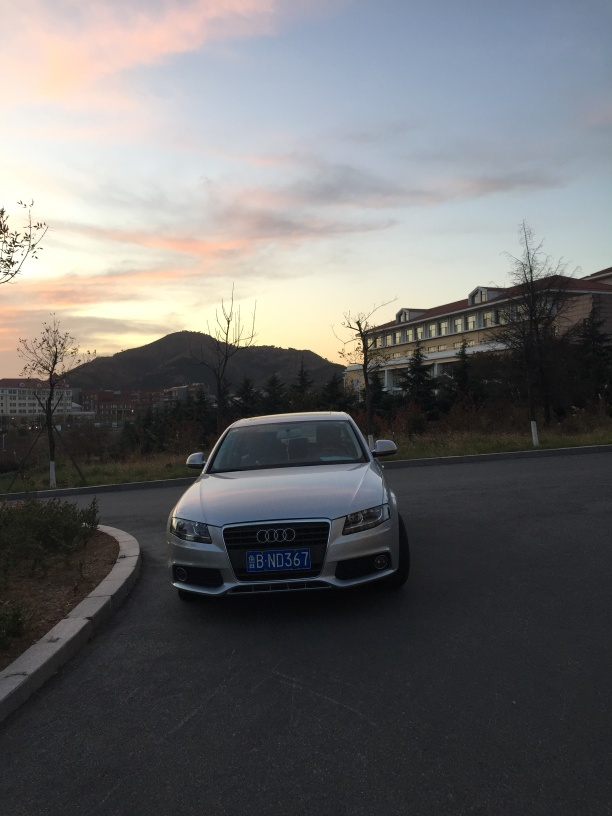What can you tell me about the car's position in the environment? The car is positioned on the side of a paved road, facing the camera. It is not parked within the designated parking spaces to the right but rather on the side of the road, which may indicate a temporary stop. This positioning allows viewers to see the car's front profile clearly against the contrasting backdrop. 